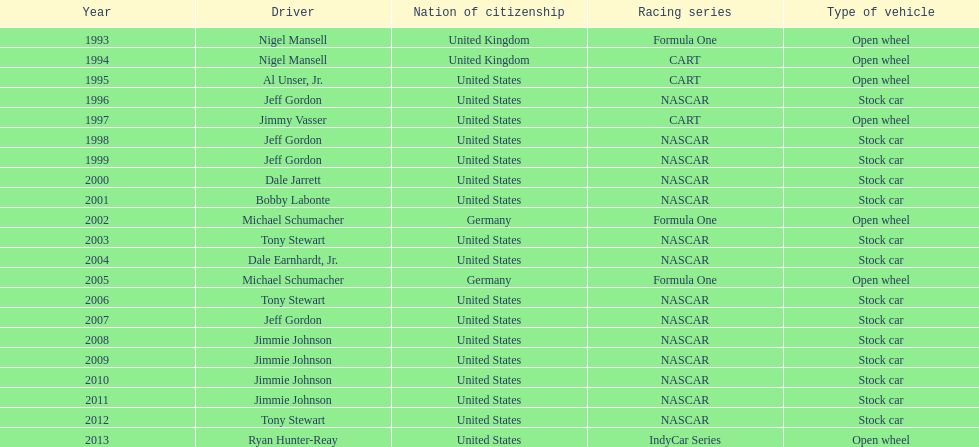Besides nascar, what other racing series have espy-winning drivers come from? Formula One, CART, IndyCar Series. 